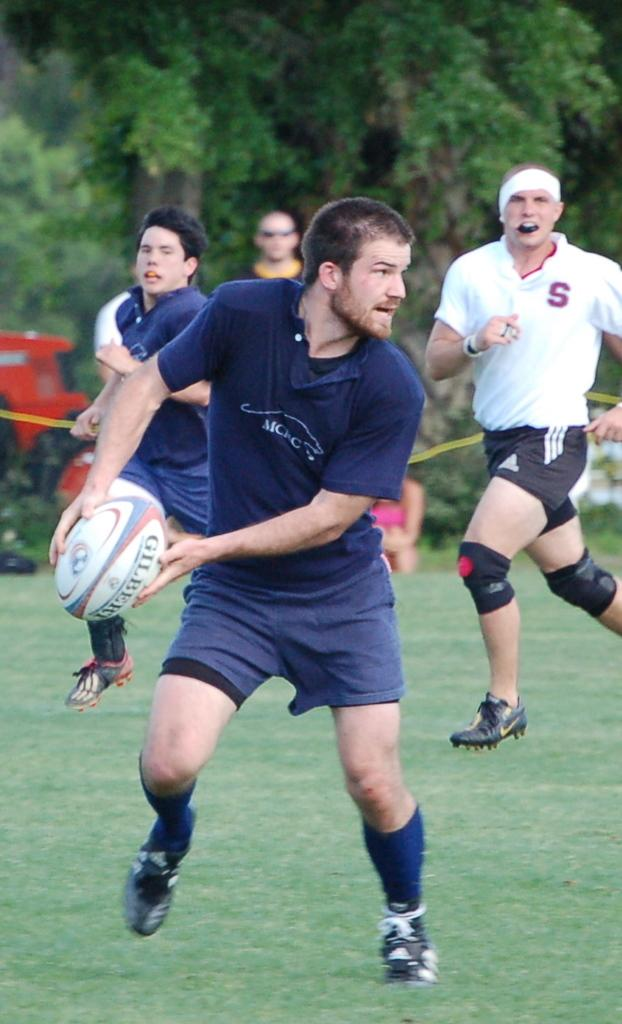What is the man in the image doing? The man is running in the image. What is the man holding while running? The man is holding a ball in his hand. Are there other people in the image besides the man? Yes, there are more people running in the image. What type of surface are the people running on? The people are running on the grass. What can be seen in the background of the image? There are many trees visible in the background. What type of cook is present in the image? There is no cook present in the image. 